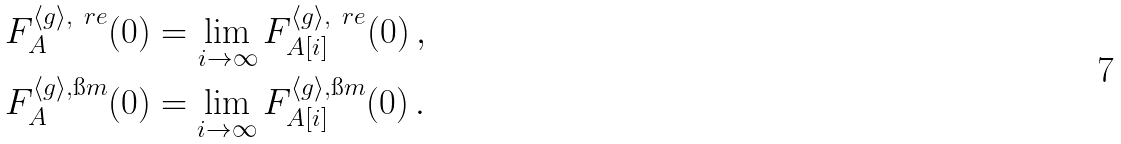<formula> <loc_0><loc_0><loc_500><loc_500>& F ^ { \langle g \rangle , \ r e } _ { A } ( 0 ) = \lim _ { i \rightarrow \infty } F ^ { \langle g \rangle , \ r e } _ { A [ i ] } ( 0 ) \, , \\ & F ^ { \langle g \rangle , \i m } _ { A } ( 0 ) = \lim _ { i \rightarrow \infty } F ^ { \langle g \rangle , \i m } _ { A [ i ] } ( 0 ) \, .</formula> 